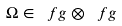<formula> <loc_0><loc_0><loc_500><loc_500>\Omega \in \ f g \otimes \ f g</formula> 